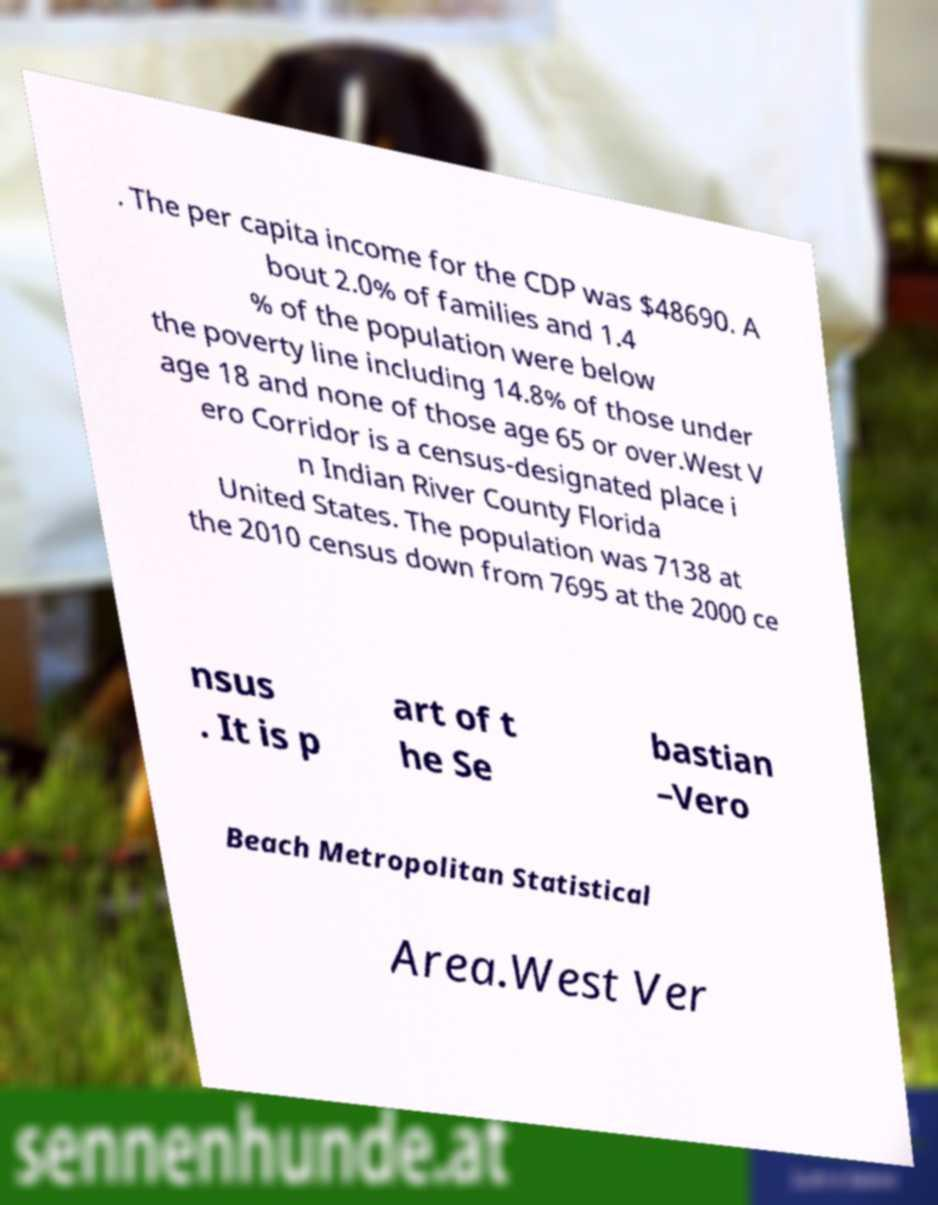Please read and relay the text visible in this image. What does it say? . The per capita income for the CDP was $48690. A bout 2.0% of families and 1.4 % of the population were below the poverty line including 14.8% of those under age 18 and none of those age 65 or over.West V ero Corridor is a census-designated place i n Indian River County Florida United States. The population was 7138 at the 2010 census down from 7695 at the 2000 ce nsus . It is p art of t he Se bastian –Vero Beach Metropolitan Statistical Area.West Ver 